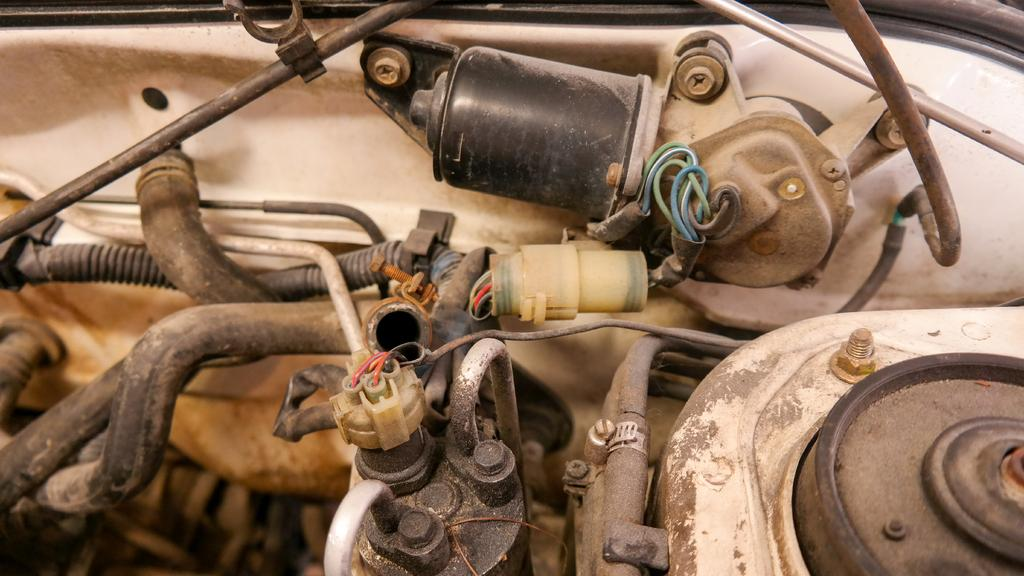What type of objects can be seen in the image? The image contains wires, motors, pipes, nuts, and rods. Can you describe the wires in the image? The image contains wires, but no further details are provided about their appearance or function. What type of objects are the motors connected to in the image? The image contains motors, but no further details are provided about their connections or function. What type of objects are the nuts used with in the image? The image contains nuts, but no further details are provided about their use or purpose. What type of objects are the rods connected to in the image? The image contains rods, but no further details are provided about their connections or function. What type of arch can be seen in the image? There is no arch present in the image. How many bubbles are floating in the image? There are no bubbles present in the image. 